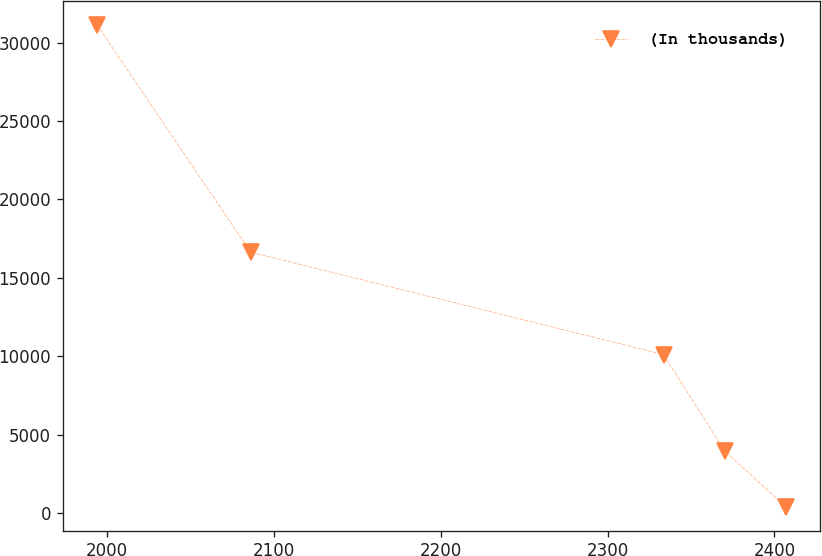Convert chart to OTSL. <chart><loc_0><loc_0><loc_500><loc_500><line_chart><ecel><fcel>(In thousands)<nl><fcel>1993.89<fcel>31113.5<nl><fcel>2085.97<fcel>16634.1<nl><fcel>2333.52<fcel>10108<nl><fcel>2370.1<fcel>3967.51<nl><fcel>2406.68<fcel>414.82<nl></chart> 